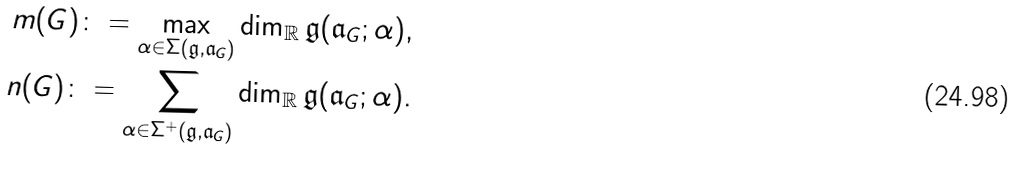Convert formula to latex. <formula><loc_0><loc_0><loc_500><loc_500>m ( G ) \colon = \max _ { \alpha \in \Sigma ( { \mathfrak { g } } , { \mathfrak { a } } _ { G } ) } \dim _ { \mathbb { R } } { \mathfrak { g } } ( { \mathfrak { a } } _ { G } ; \alpha ) , \\ n ( G ) \colon = \sum _ { \alpha \in \Sigma ^ { + } ( { \mathfrak { g } } , { \mathfrak { a } } _ { G } ) } \dim _ { \mathbb { R } } { \mathfrak { g } } ( { \mathfrak { a } } _ { G } ; \alpha ) .</formula> 